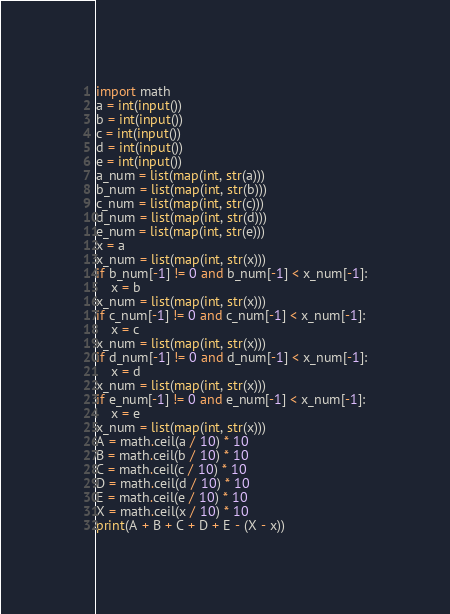<code> <loc_0><loc_0><loc_500><loc_500><_Python_>import math
a = int(input())
b = int(input())
c = int(input())
d = int(input())
e = int(input())
a_num = list(map(int, str(a)))
b_num = list(map(int, str(b)))
c_num = list(map(int, str(c)))
d_num = list(map(int, str(d)))
e_num = list(map(int, str(e)))
x = a
x_num = list(map(int, str(x)))
if b_num[-1] != 0 and b_num[-1] < x_num[-1]:
    x = b
x_num = list(map(int, str(x)))
if c_num[-1] != 0 and c_num[-1] < x_num[-1]:
    x = c
x_num = list(map(int, str(x)))
if d_num[-1] != 0 and d_num[-1] < x_num[-1]:
    x = d
x_num = list(map(int, str(x)))
if e_num[-1] != 0 and e_num[-1] < x_num[-1]:
    x = e
x_num = list(map(int, str(x)))
A = math.ceil(a / 10) * 10
B = math.ceil(b / 10) * 10
C = math.ceil(c / 10) * 10
D = math.ceil(d / 10) * 10
E = math.ceil(e / 10) * 10
X = math.ceil(x / 10) * 10
print(A + B + C + D + E - (X - x))</code> 